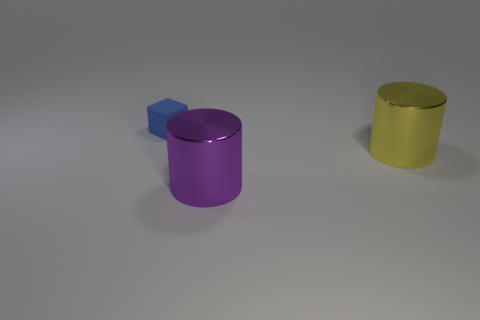Are there any other things that are made of the same material as the blue thing?
Provide a succinct answer. No. Are there any other things that are the same size as the cube?
Offer a very short reply. No. Are there fewer blue objects than tiny gray rubber cylinders?
Provide a succinct answer. No. There is another metallic object that is the same shape as the purple shiny thing; what is its color?
Your answer should be compact. Yellow. Is there anything else that is the same shape as the tiny blue rubber object?
Offer a very short reply. No. Is the number of large brown rubber spheres greater than the number of yellow objects?
Your answer should be compact. No. How many other things are made of the same material as the tiny blue object?
Provide a succinct answer. 0. What shape is the thing left of the metallic object that is in front of the large shiny cylinder behind the purple metallic cylinder?
Provide a succinct answer. Cube. Are there fewer tiny cubes on the right side of the blue thing than blue objects that are left of the large yellow cylinder?
Your answer should be compact. Yes. Does the tiny object have the same material as the big thing that is in front of the yellow cylinder?
Offer a terse response. No. 